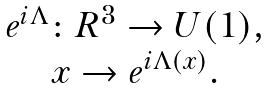Convert formula to latex. <formula><loc_0><loc_0><loc_500><loc_500>\begin{array} { c } { { e ^ { i \Lambda } \colon { R } ^ { 3 } \rightarrow U ( 1 ) , } } \\ { { x \rightarrow e ^ { i \Lambda ( x ) } . } } \end{array}</formula> 